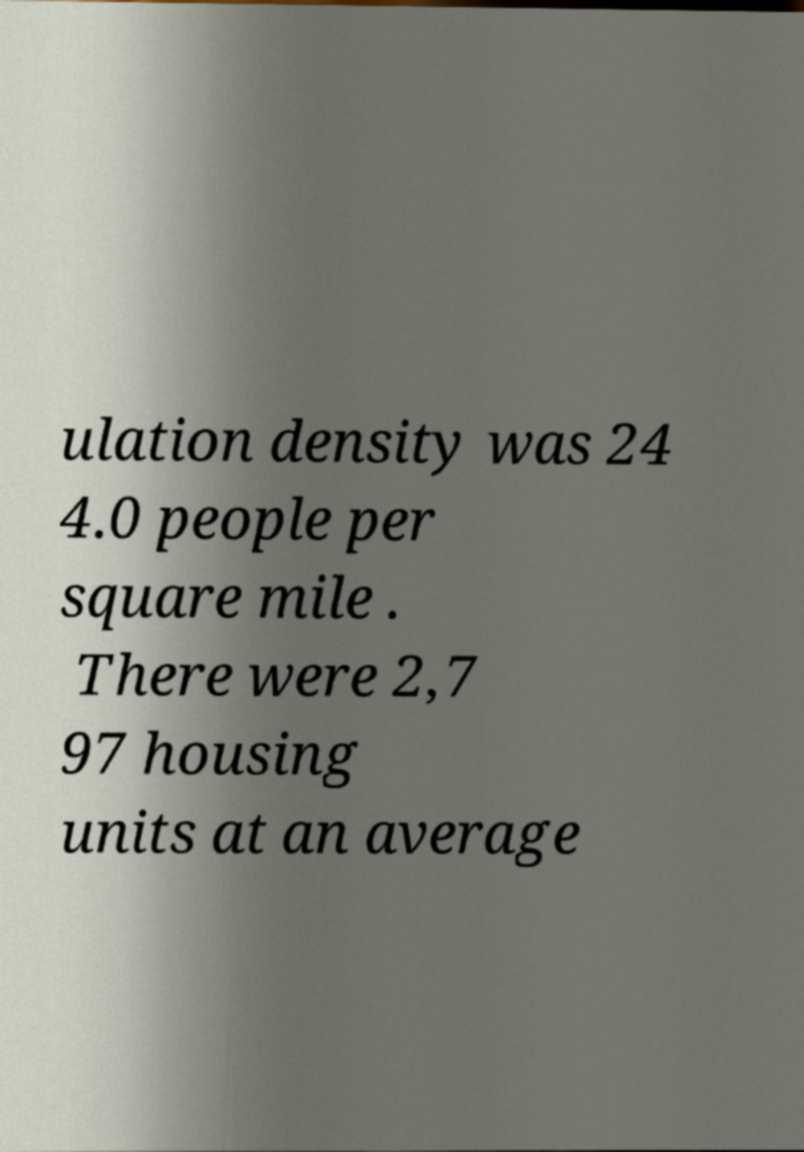Please identify and transcribe the text found in this image. ulation density was 24 4.0 people per square mile . There were 2,7 97 housing units at an average 